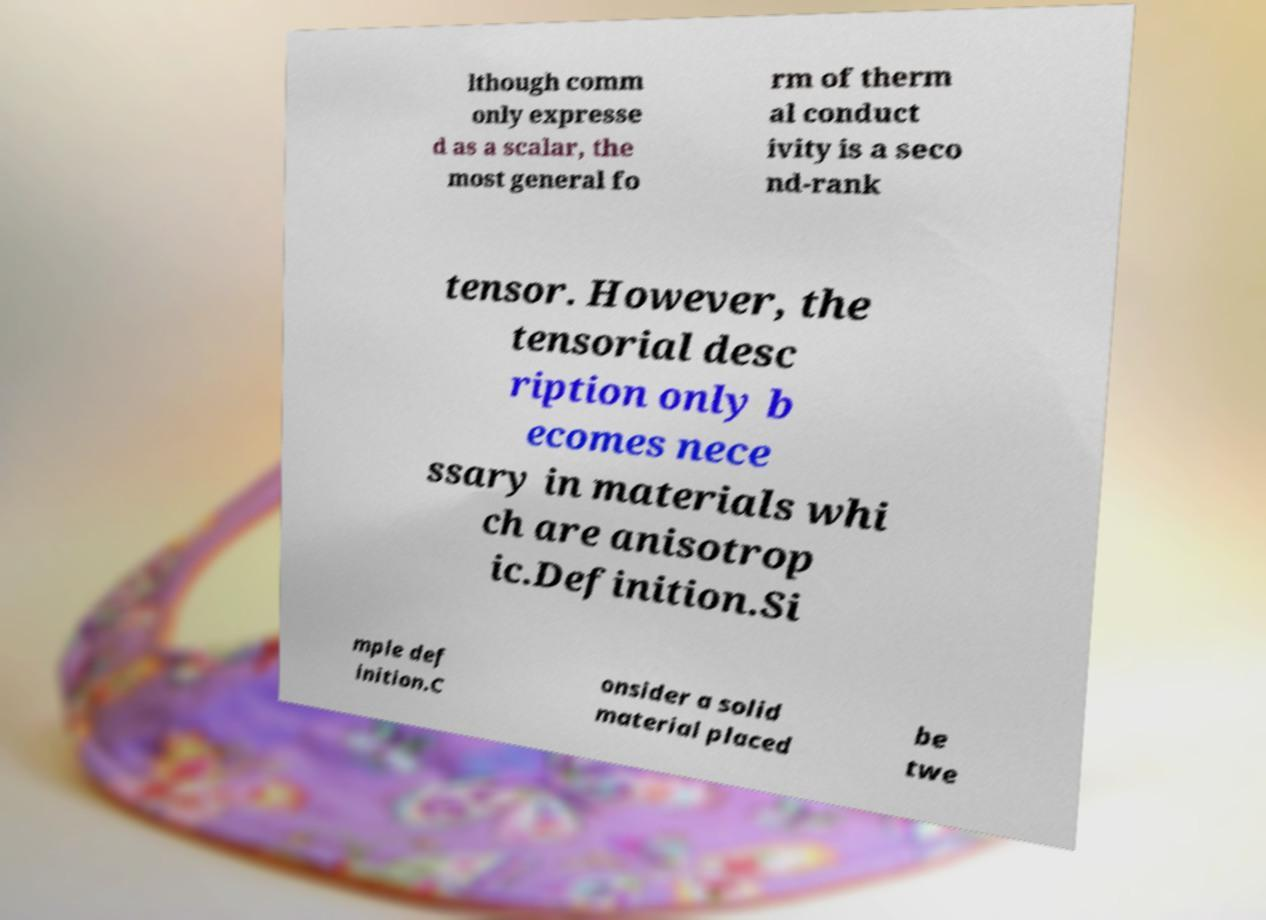What messages or text are displayed in this image? I need them in a readable, typed format. lthough comm only expresse d as a scalar, the most general fo rm of therm al conduct ivity is a seco nd-rank tensor. However, the tensorial desc ription only b ecomes nece ssary in materials whi ch are anisotrop ic.Definition.Si mple def inition.C onsider a solid material placed be twe 